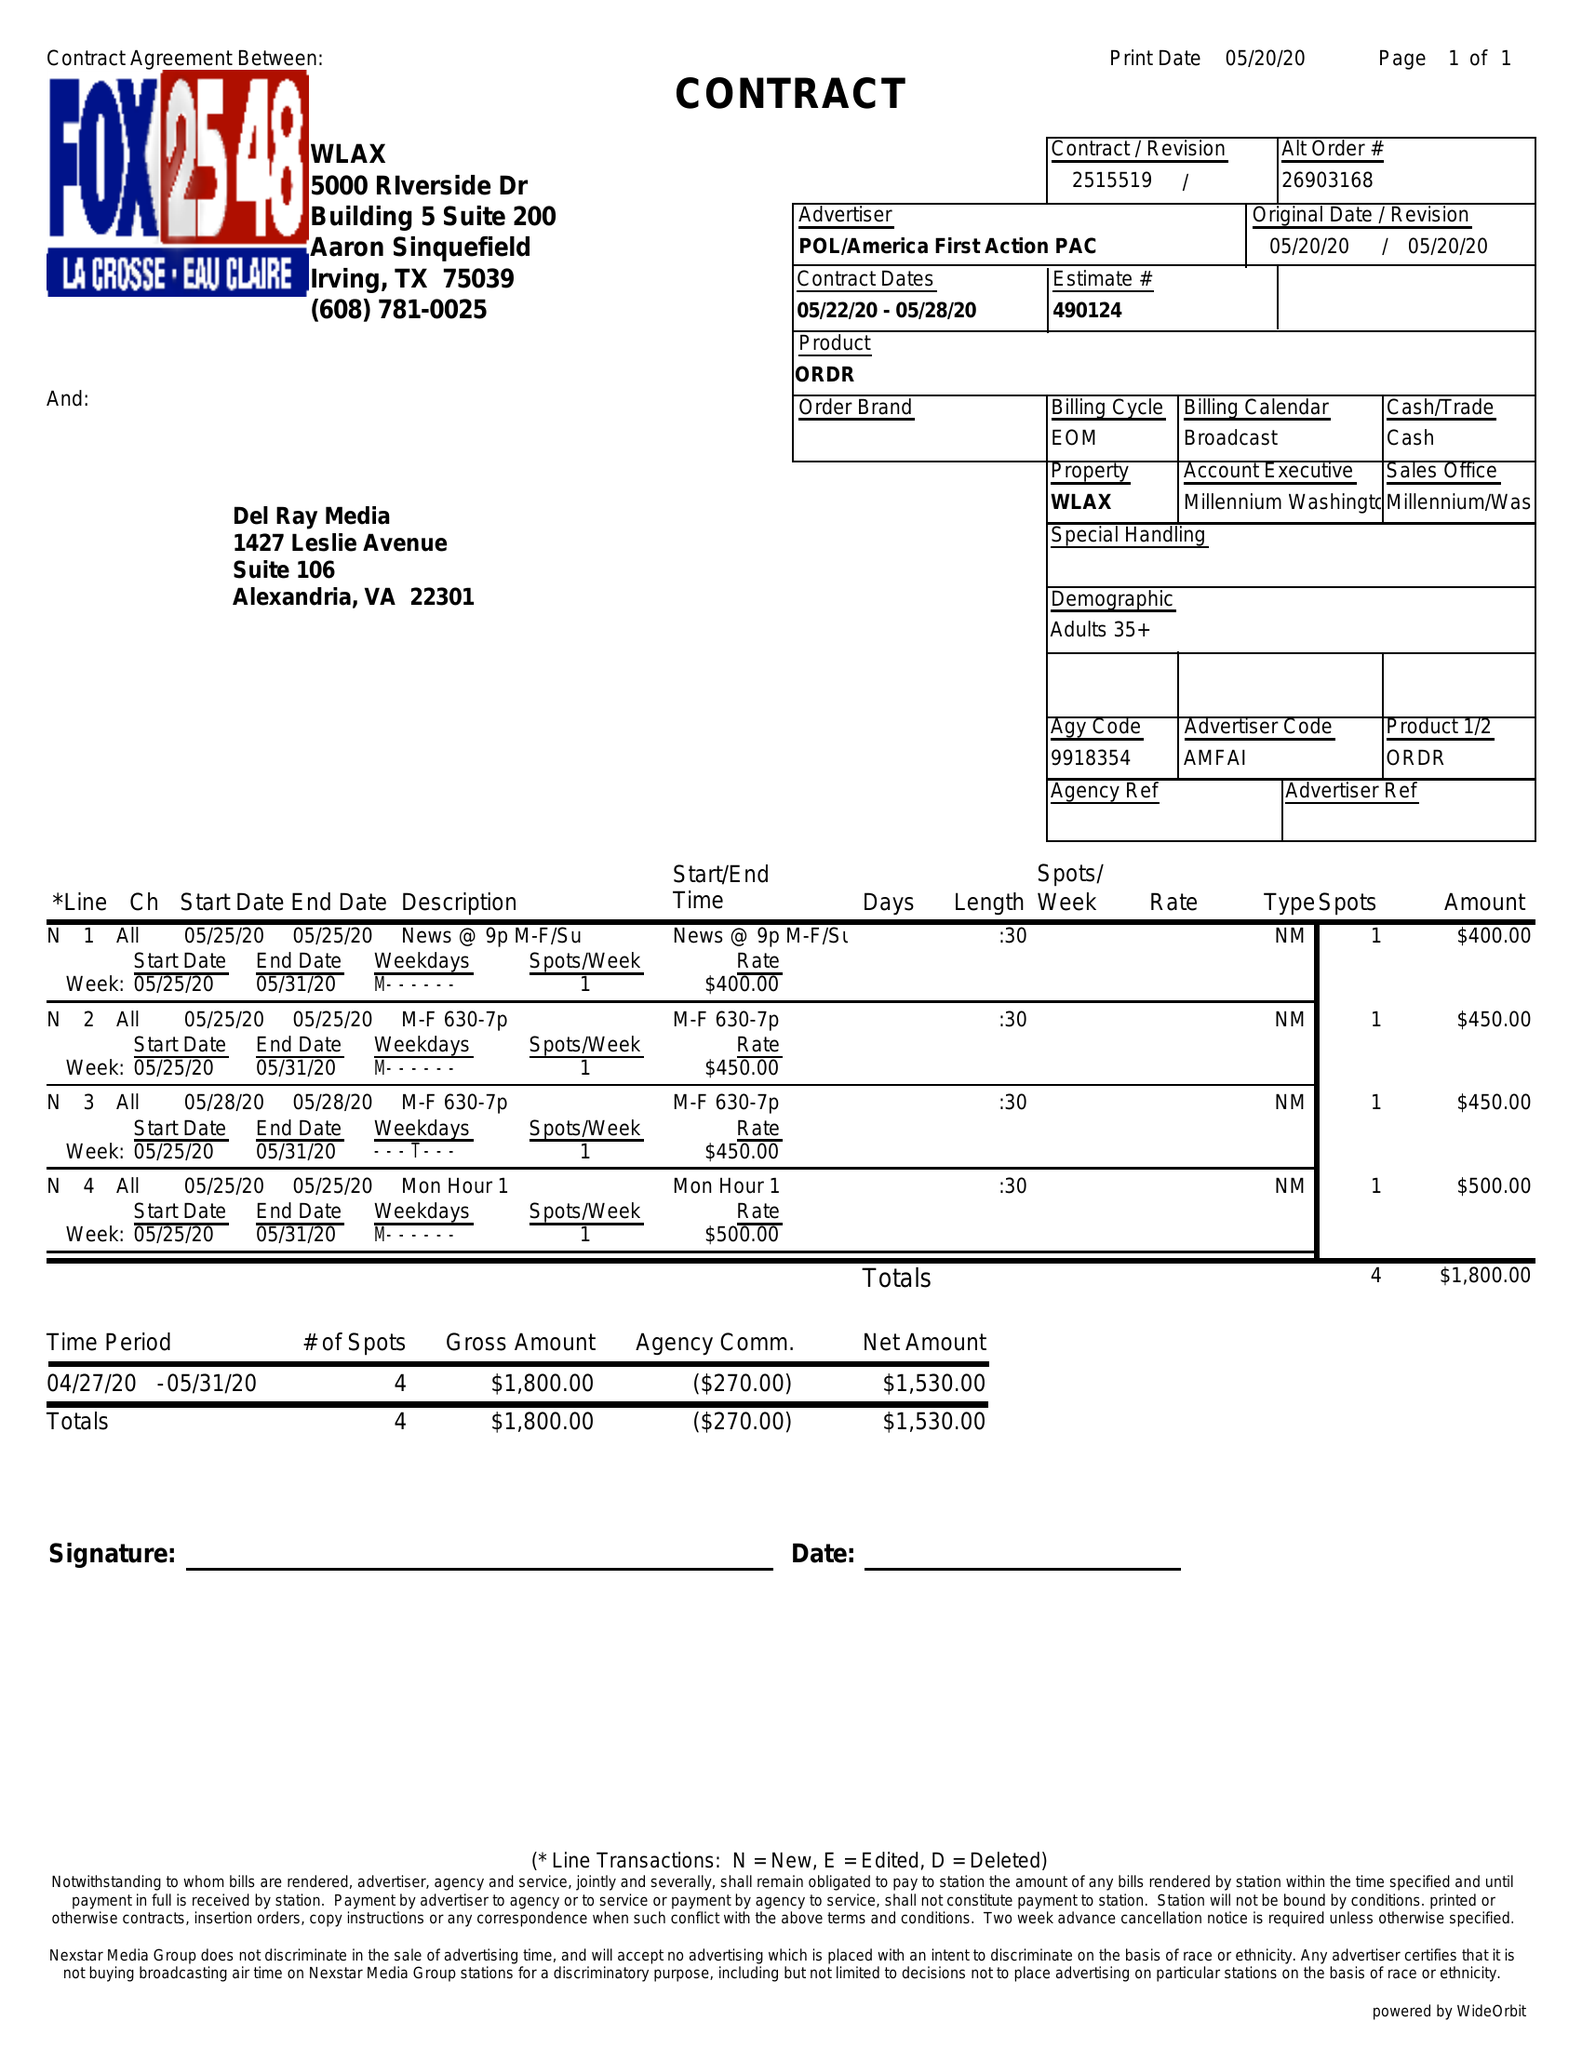What is the value for the gross_amount?
Answer the question using a single word or phrase. 1800.00 